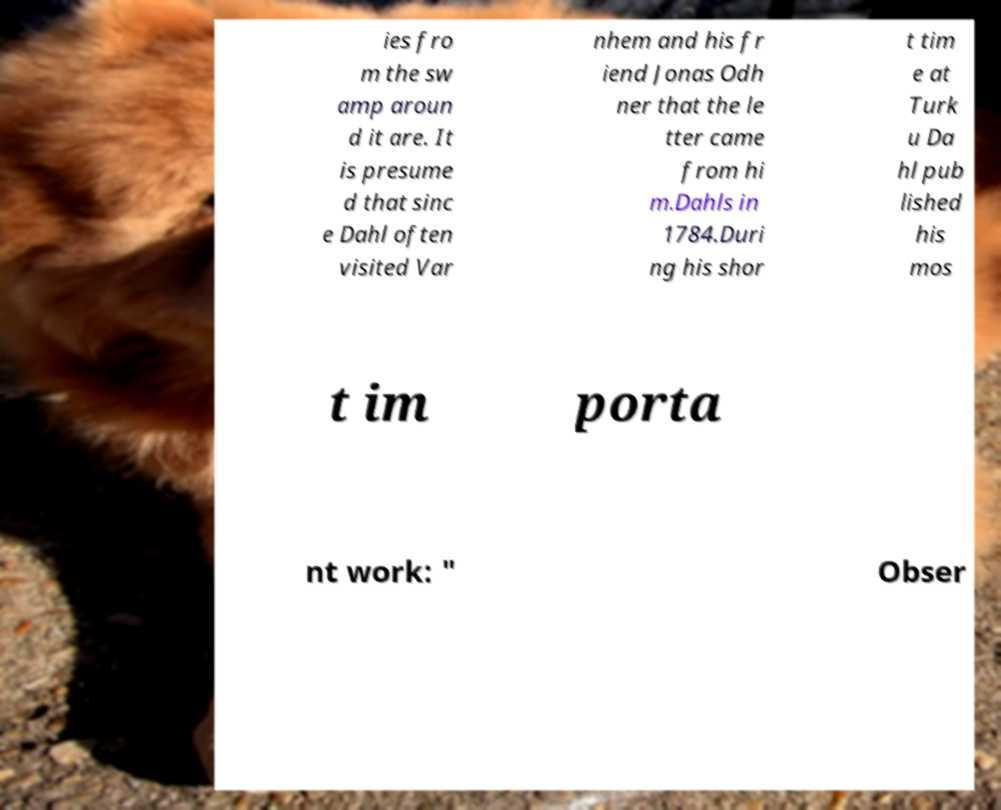For documentation purposes, I need the text within this image transcribed. Could you provide that? ies fro m the sw amp aroun d it are. It is presume d that sinc e Dahl often visited Var nhem and his fr iend Jonas Odh ner that the le tter came from hi m.Dahls in 1784.Duri ng his shor t tim e at Turk u Da hl pub lished his mos t im porta nt work: " Obser 